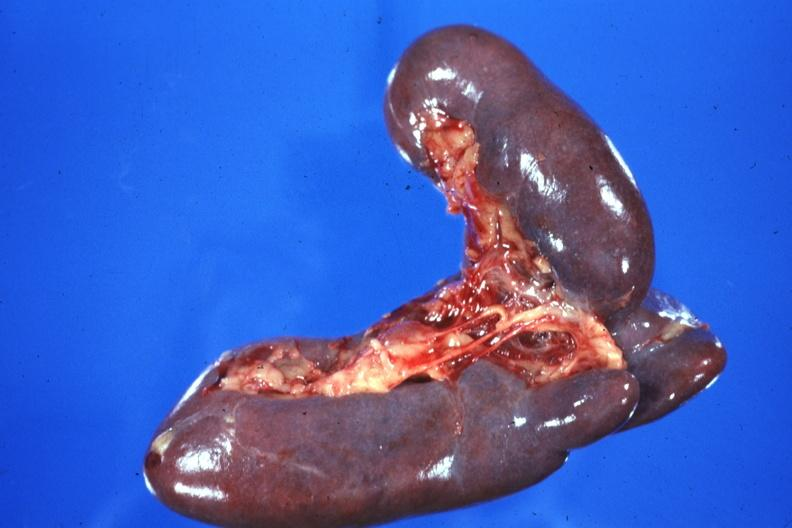s spleen present?
Answer the question using a single word or phrase. Yes 